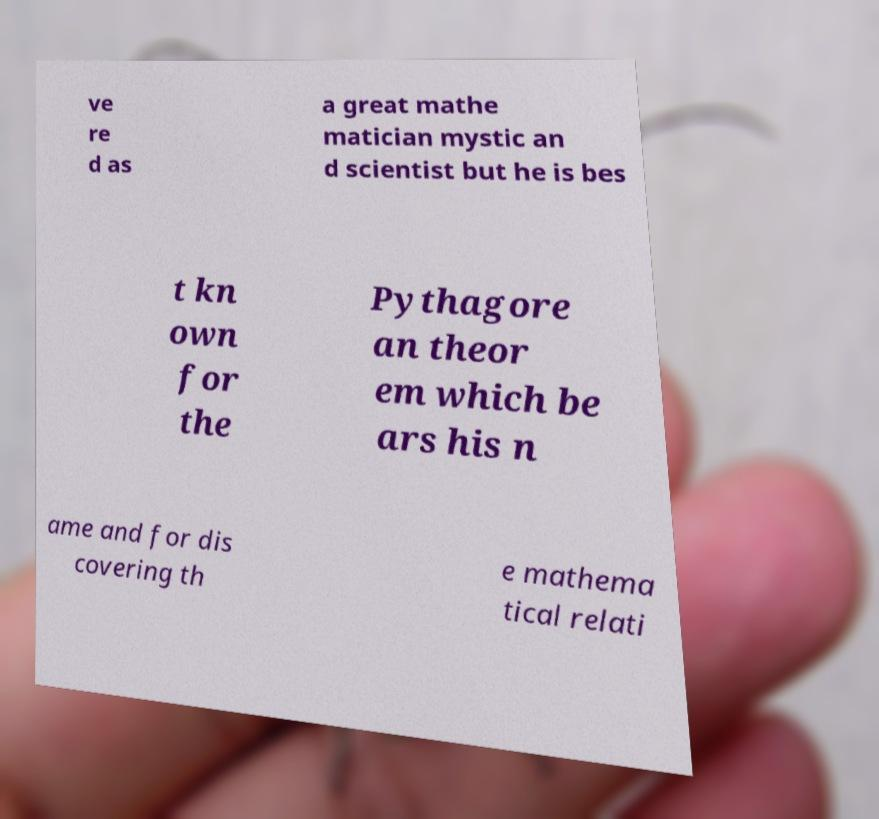There's text embedded in this image that I need extracted. Can you transcribe it verbatim? ve re d as a great mathe matician mystic an d scientist but he is bes t kn own for the Pythagore an theor em which be ars his n ame and for dis covering th e mathema tical relati 